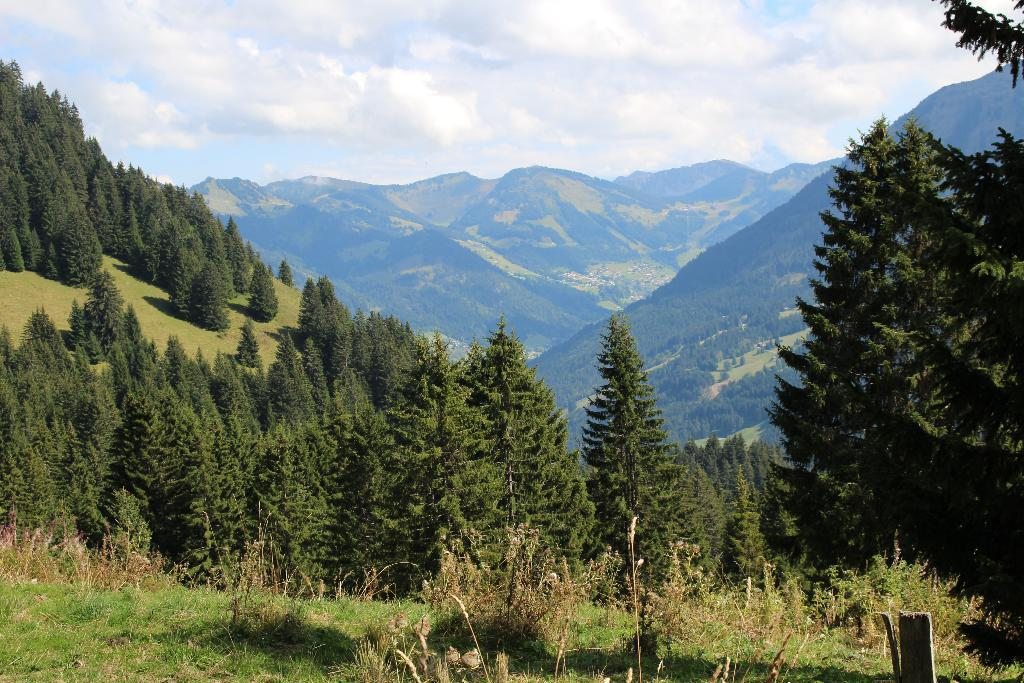What type of vegetation is at the bottom of the image? There is grass at the bottom of the image. What can be seen in the middle of the image? There are trees in the middle of the image. What type of landscape feature is visible in the background of the image? There are hills visible in the background of the image. What is visible in the sky in the image? The sky is visible in the image, and clouds are present. What type of downtown area can be seen in the image? There is no downtown area present in the image; it features grass, trees, hills, and clouds. What kind of trouble is the boot causing in the image? There is no boot present in the image, so it cannot be causing any trouble. 